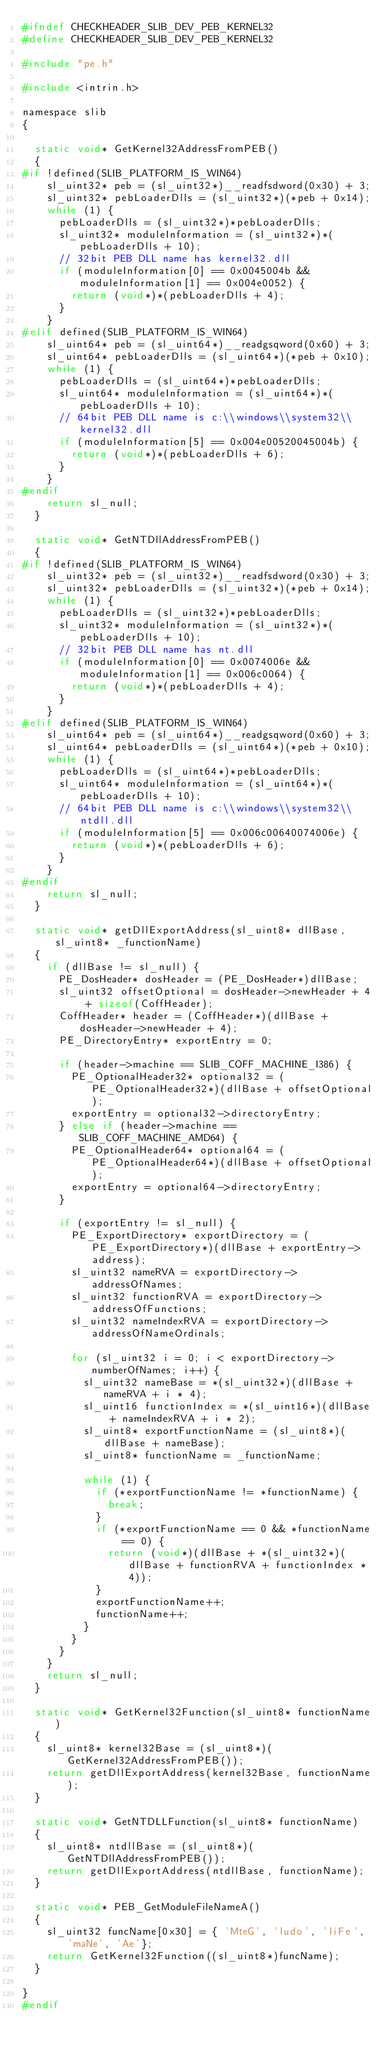Convert code to text. <code><loc_0><loc_0><loc_500><loc_500><_C_>#ifndef CHECKHEADER_SLIB_DEV_PEB_KERNEL32
#define CHECKHEADER_SLIB_DEV_PEB_KERNEL32

#include "pe.h"

#include <intrin.h>

namespace slib
{

	static void* GetKernel32AddressFromPEB()
	{
#if !defined(SLIB_PLATFORM_IS_WIN64)
		sl_uint32* peb = (sl_uint32*)__readfsdword(0x30) + 3;
		sl_uint32* pebLoaderDlls = (sl_uint32*)(*peb + 0x14);
		while (1) {
			pebLoaderDlls = (sl_uint32*)*pebLoaderDlls;
			sl_uint32* moduleInformation = (sl_uint32*)*(pebLoaderDlls + 10);
			// 32bit PEB DLL name has kernel32.dll
			if (moduleInformation[0] == 0x0045004b && moduleInformation[1] == 0x004e0052) {
				return (void*)*(pebLoaderDlls + 4);
			}
		}
#elif defined(SLIB_PLATFORM_IS_WIN64)
		sl_uint64* peb = (sl_uint64*)__readgsqword(0x60) + 3;
		sl_uint64* pebLoaderDlls = (sl_uint64*)(*peb + 0x10);
		while (1) {
			pebLoaderDlls = (sl_uint64*)*pebLoaderDlls;
			sl_uint64* moduleInformation = (sl_uint64*)*(pebLoaderDlls + 10);
			// 64bit PEB DLL name is c:\\windows\\system32\\kernel32.dll
			if (moduleInformation[5] == 0x004e00520045004b) {
				return (void*)*(pebLoaderDlls + 6);
			}
		}
#endif
		return sl_null;
	}

	static void* GetNTDllAddressFromPEB()
	{
#if !defined(SLIB_PLATFORM_IS_WIN64)
		sl_uint32* peb = (sl_uint32*)__readfsdword(0x30) + 3;
		sl_uint32* pebLoaderDlls = (sl_uint32*)(*peb + 0x14);
		while (1) {
			pebLoaderDlls = (sl_uint32*)*pebLoaderDlls;
			sl_uint32* moduleInformation = (sl_uint32*)*(pebLoaderDlls + 10);
			// 32bit PEB DLL name has nt.dll
			if (moduleInformation[0] == 0x0074006e && moduleInformation[1] == 0x006c0064) {
				return (void*)*(pebLoaderDlls + 4);
			}
		}
#elif defined(SLIB_PLATFORM_IS_WIN64)
		sl_uint64* peb = (sl_uint64*)__readgsqword(0x60) + 3;
		sl_uint64* pebLoaderDlls = (sl_uint64*)(*peb + 0x10);
		while (1) {
			pebLoaderDlls = (sl_uint64*)*pebLoaderDlls;
			sl_uint64* moduleInformation = (sl_uint64*)*(pebLoaderDlls + 10);
			// 64bit PEB DLL name is c:\\windows\\system32\\ntdll.dll
			if (moduleInformation[5] == 0x006c00640074006e) {
				return (void*)*(pebLoaderDlls + 6);
			}
		}
#endif
		return sl_null;
	}

	static void* getDllExportAddress(sl_uint8* dllBase, sl_uint8* _functionName)
	{
		if (dllBase != sl_null) {
			PE_DosHeader* dosHeader = (PE_DosHeader*)dllBase;
			sl_uint32 offsetOptional = dosHeader->newHeader + 4 + sizeof(CoffHeader);
			CoffHeader* header = (CoffHeader*)(dllBase + dosHeader->newHeader + 4);
			PE_DirectoryEntry* exportEntry = 0;

			if (header->machine == SLIB_COFF_MACHINE_I386) {
				PE_OptionalHeader32* optional32 = (PE_OptionalHeader32*)(dllBase + offsetOptional);
				exportEntry = optional32->directoryEntry;
			} else if (header->machine == SLIB_COFF_MACHINE_AMD64) {
				PE_OptionalHeader64* optional64 = (PE_OptionalHeader64*)(dllBase + offsetOptional);
				exportEntry = optional64->directoryEntry;
			}

			if (exportEntry != sl_null) {
				PE_ExportDirectory* exportDirectory = (PE_ExportDirectory*)(dllBase + exportEntry->address);
				sl_uint32 nameRVA = exportDirectory->addressOfNames;
				sl_uint32 functionRVA = exportDirectory->addressOfFunctions;
				sl_uint32 nameIndexRVA = exportDirectory->addressOfNameOrdinals;

				for (sl_uint32 i = 0; i < exportDirectory->numberOfNames; i++) {
					sl_uint32 nameBase = *(sl_uint32*)(dllBase + nameRVA + i * 4);
					sl_uint16 functionIndex = *(sl_uint16*)(dllBase + nameIndexRVA + i * 2);
					sl_uint8* exportFunctionName = (sl_uint8*)(dllBase + nameBase);
					sl_uint8* functionName = _functionName;

					while (1) {
						if (*exportFunctionName != *functionName) {
							break;
						}
						if (*exportFunctionName == 0 && *functionName == 0) {
							return (void*)(dllBase + *(sl_uint32*)(dllBase + functionRVA + functionIndex * 4));
						}
						exportFunctionName++;
						functionName++;
					}
				}
			}
		}
		return sl_null;
	}

	static void* GetKernel32Function(sl_uint8* functionName)
	{
		sl_uint8* kernel32Base = (sl_uint8*)(GetKernel32AddressFromPEB());
		return getDllExportAddress(kernel32Base, functionName);
	}

	static void* GetNTDLLFunction(sl_uint8* functionName)
	{
		sl_uint8* ntdllBase = (sl_uint8*)(GetNTDllAddressFromPEB());
		return getDllExportAddress(ntdllBase, functionName);
	}

	static void* PEB_GetModuleFileNameA()
	{
		sl_uint32 funcName[0x30] = { 'MteG', 'ludo', 'liFe', 'maNe', 'Ae'};
		return GetKernel32Function((sl_uint8*)funcName);
	}

}
#endif</code> 